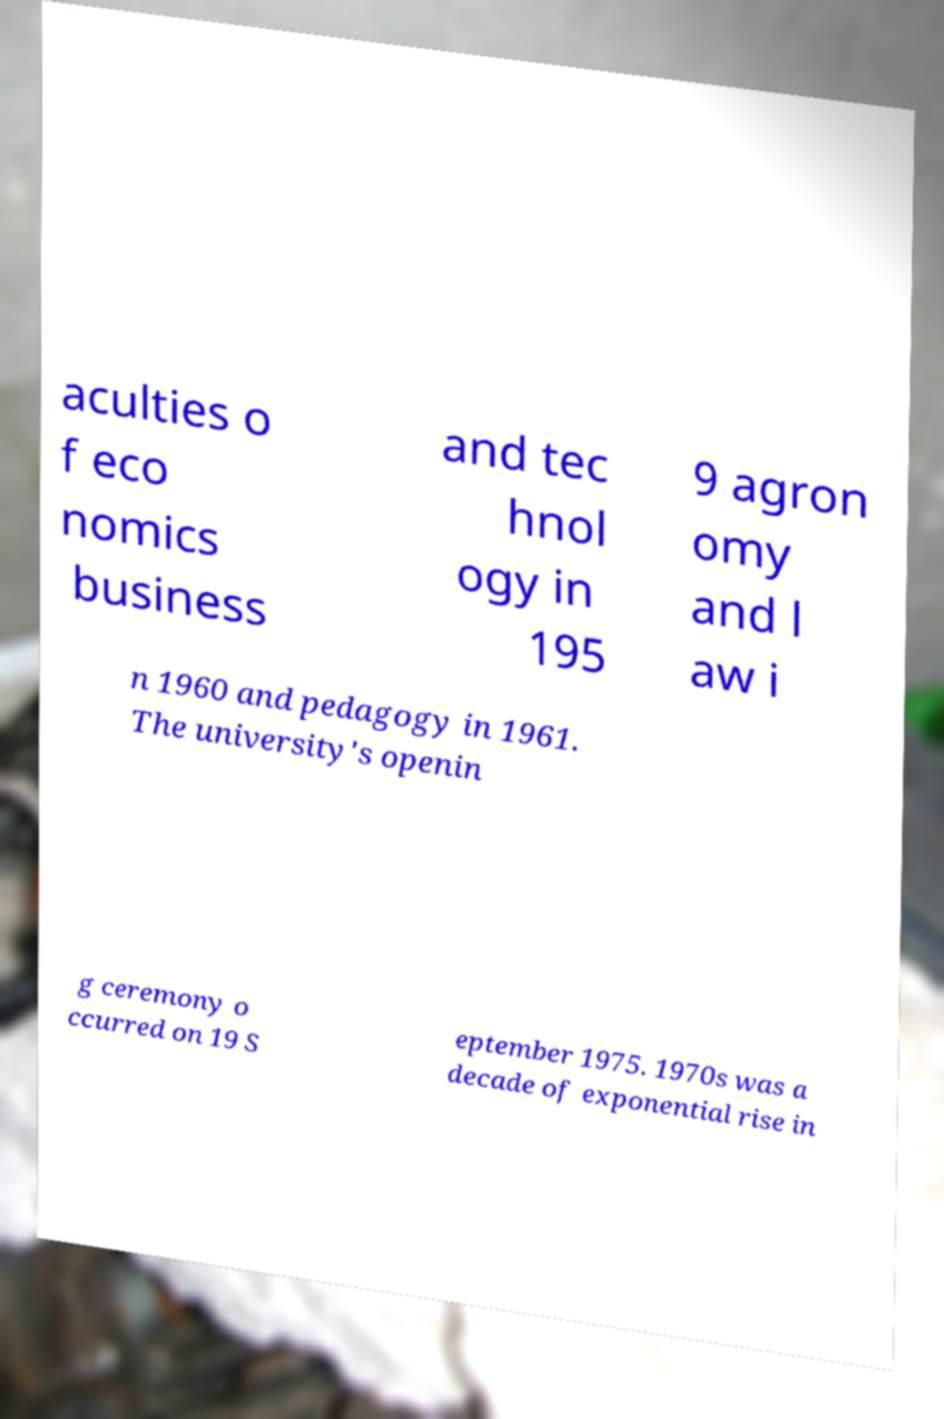Could you extract and type out the text from this image? aculties o f eco nomics business and tec hnol ogy in 195 9 agron omy and l aw i n 1960 and pedagogy in 1961. The university's openin g ceremony o ccurred on 19 S eptember 1975. 1970s was a decade of exponential rise in 